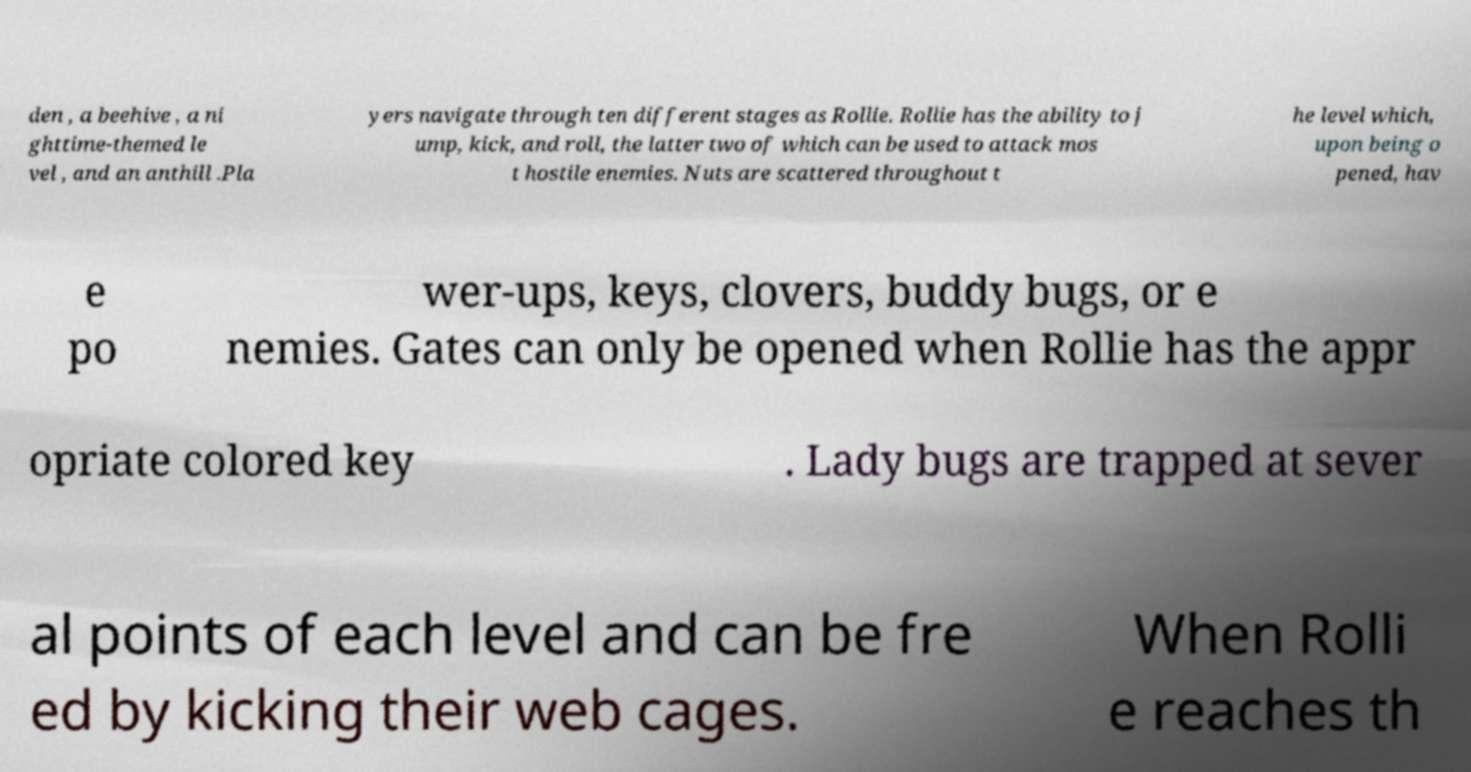Could you extract and type out the text from this image? den , a beehive , a ni ghttime-themed le vel , and an anthill .Pla yers navigate through ten different stages as Rollie. Rollie has the ability to j ump, kick, and roll, the latter two of which can be used to attack mos t hostile enemies. Nuts are scattered throughout t he level which, upon being o pened, hav e po wer-ups, keys, clovers, buddy bugs, or e nemies. Gates can only be opened when Rollie has the appr opriate colored key . Lady bugs are trapped at sever al points of each level and can be fre ed by kicking their web cages. When Rolli e reaches th 